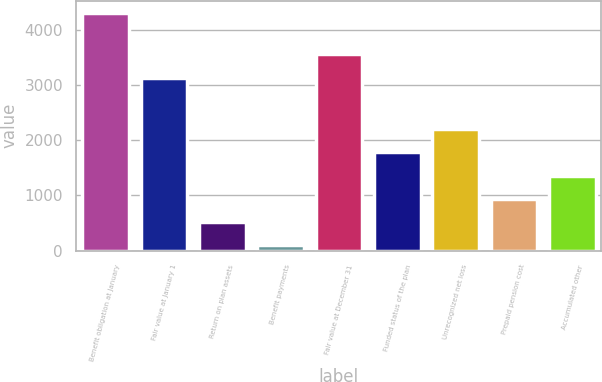Convert chart to OTSL. <chart><loc_0><loc_0><loc_500><loc_500><bar_chart><fcel>Benefit obligation at January<fcel>Fair value at January 1<fcel>Return on plan assets<fcel>Benefit payments<fcel>Fair value at December 31<fcel>Funded status of the plan<fcel>Unrecognized net loss<fcel>Prepaid pension cost<fcel>Accumulated other<nl><fcel>4304<fcel>3130<fcel>518.6<fcel>98<fcel>3550.6<fcel>1780.4<fcel>2201<fcel>939.2<fcel>1359.8<nl></chart> 